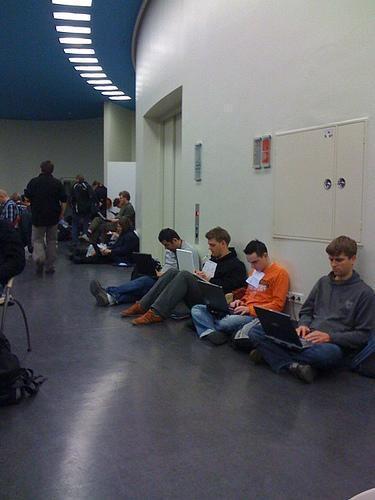What are the men against the wall working on?
From the following set of four choices, select the accurate answer to respond to the question.
Options: Ipods, tablets, laptop, desktops. Laptop. 